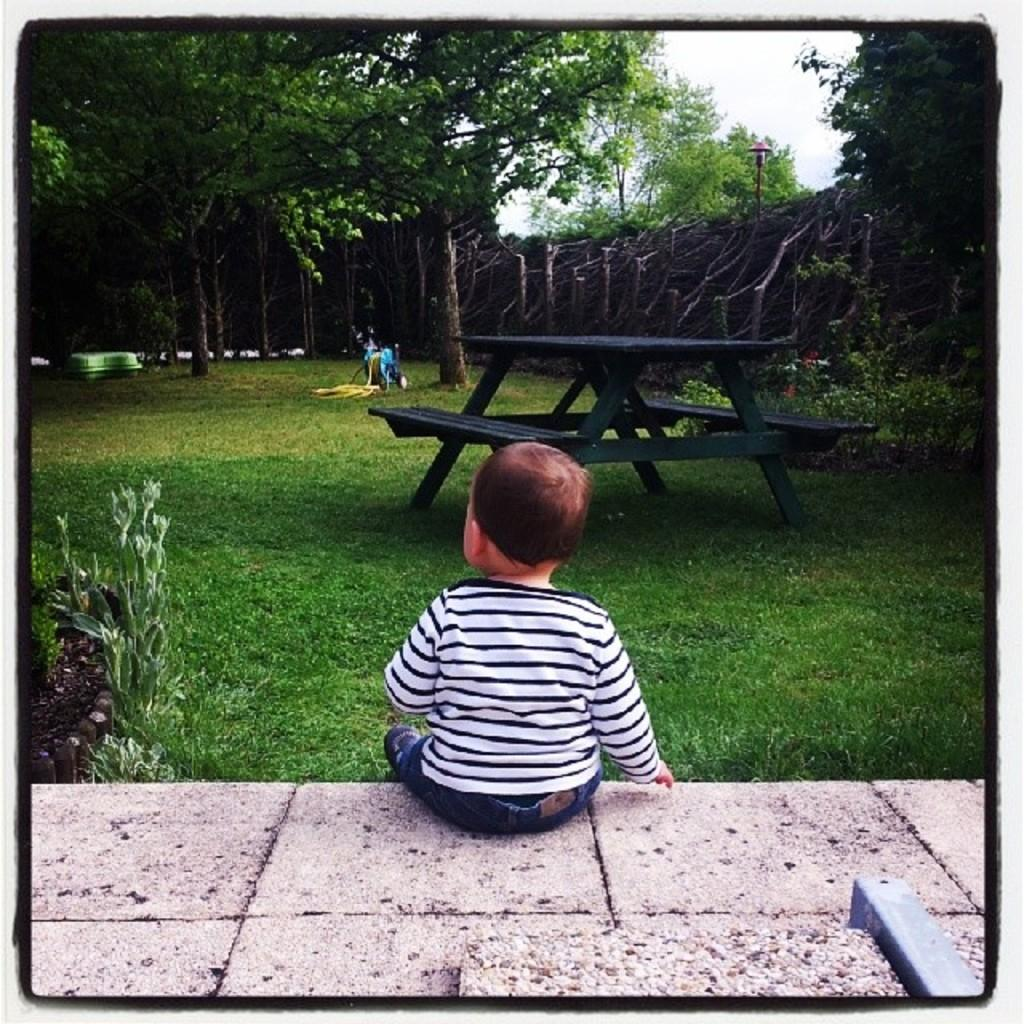What type of outdoor area is shown in the image? The image depicts a garden or lawn. What is the kid doing in the image? The kid is sitting on a rock. What object is in front of the kid? There is a big table in front of the kid. What type of vegetation is present in the image? Grass is present in the image. What can be seen in the background of the image? There are trees and the sky visible in the background of the image. What type of pain is the kid experiencing while sitting on the rock in the image? There is no indication in the image that the kid is experiencing any pain. What type of class is being held in the garden in the image? There is no class or educational activity depicted in the image. 